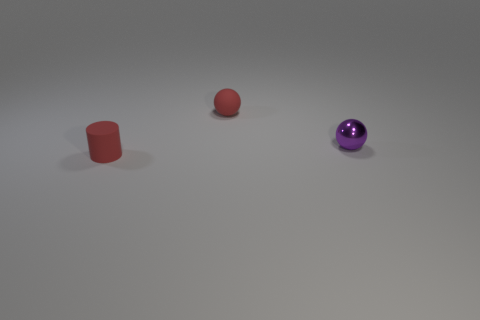What could these three objects represent if they were symbols in a story? In a symbolic context, these three objects could represent various stages or aspects of life. The cylinder might symbolize stability and the foundation of life's structure, the sphere could represent wholeness and completeness, and the shiny orb could symbolize the pursuit of perfection or enlightenment. Together, they may imply a narrative of personal growth or the journey of a character through different stages. 